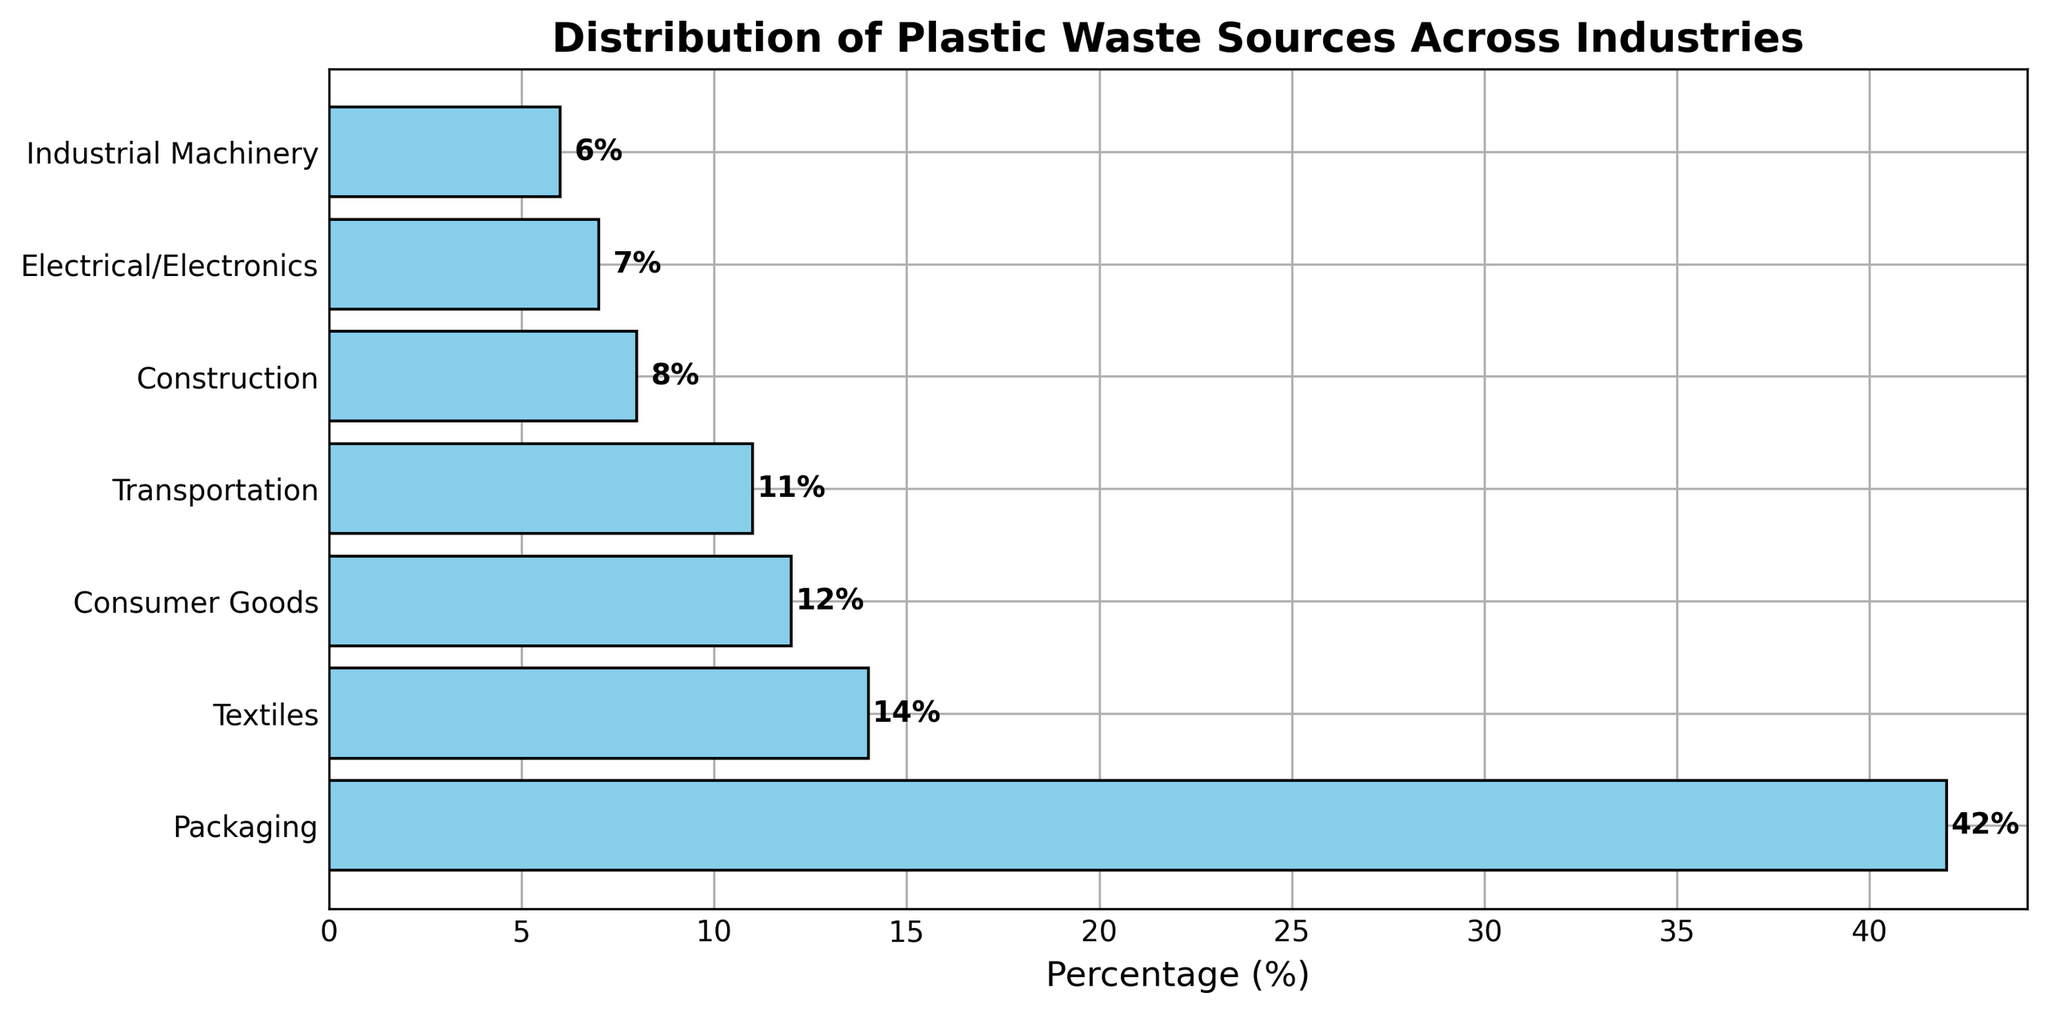Which industry contributes the most to plastic waste? Packaging has the highest percentage bar and the text label of 42%, indicating it contributes the most to plastic waste.
Answer: Packaging Among Textiles, Consumer Goods, and Transportation, which industry contributes the least to plastic waste? Comparing the percentage values of Textiles (14%), Consumer Goods (12%), and Transportation (11%), Transportation has the smallest percentage bar and the text label of 11%.
Answer: Transportation What is the combined percentage of plastic waste from Construction and Industrial Machinery? The percentage for Construction is 8%, and for Industrial Machinery, it is 6%. Adding these gives 8% + 6% = 14%.
Answer: 14% Is the percentage contribution of Electrical/Electronics higher or lower than Transportation? Electrical/Electronics has a percentage contribution of 7%, while Transportation has 11%. Since 7% is less than 11%, Electrical/Electronics is lower.
Answer: Lower Which two industries have the percentage contribution closest to each other? Comparing the percentages, Consumer Goods at 12% and Transportation at 11% are the closest, with a difference of only 1%.
Answer: Consumer Goods and Transportation How much more does Packaging contribute to plastic waste compared to Textiles? Packaging contributes 42%, and Textiles contribute 14%. The difference is 42% - 14% = 28%.
Answer: 28% What percentage of plastic waste is contributed by industries other than Packaging? The percentages for the other industries are summed: 14% (Textiles) + 12% (Consumer Goods) + 11% (Transportation) + 8% (Construction) + 7% (Electrical/Electronics) + 6% (Industrial Machinery) = 58%.
Answer: 58% What percentage of plastic waste is contributed by Consumer Goods and Electrical/Electronics combined? The percentages for Consumer Goods and Electrical/Electronics are summed: 12% (Consumer Goods) + 7% (Electrical/Electronics) = 19%.
Answer: 19% Is there any industry with a double-digit percentage that contributes less than 15% to plastic waste? Textiles (14%), Consumer Goods (12%), and Transportation (11%) all fit this criterion.
Answer: Yes 